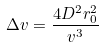<formula> <loc_0><loc_0><loc_500><loc_500>\Delta v = \frac { 4 D ^ { 2 } r _ { 0 } ^ { 2 } } { v ^ { 3 } }</formula> 